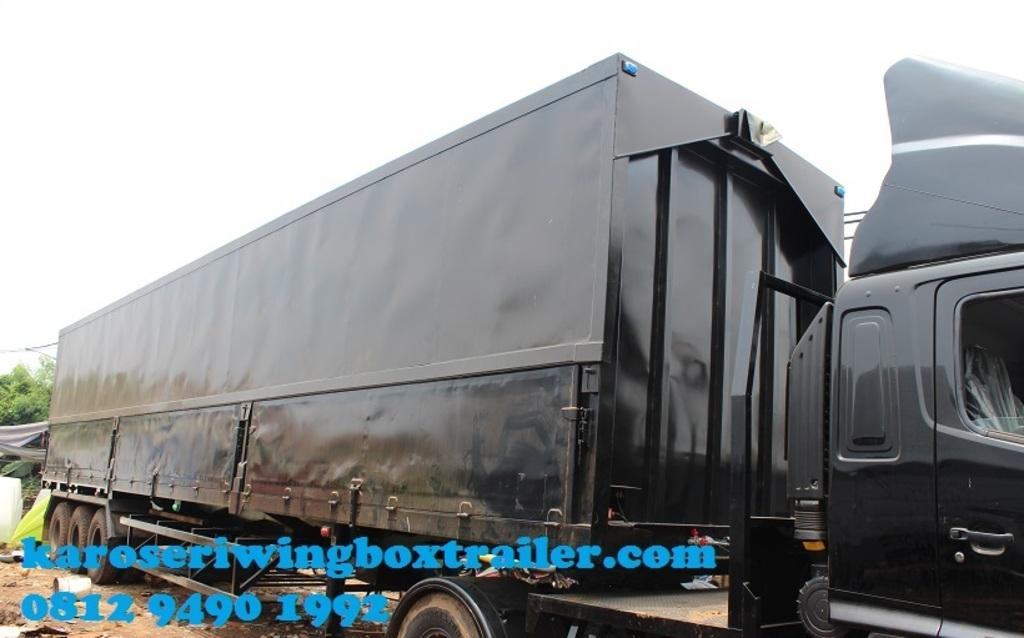What is the main object in the image? There is a truck container in the image. What can be seen on the left side of the image? There are trees on the left side of the image. What is visible in the background of the image? There is sky visible in the background of the image. Can you describe any text or writing in the image? Yes, there is text or writing on the image. How many icicles are hanging from the truck container in the image? There are no icicles present in the image. What type of rifle is depicted in the text or writing on the image? There is no rifle depicted in the image, as the provided facts do not mention any such object. 